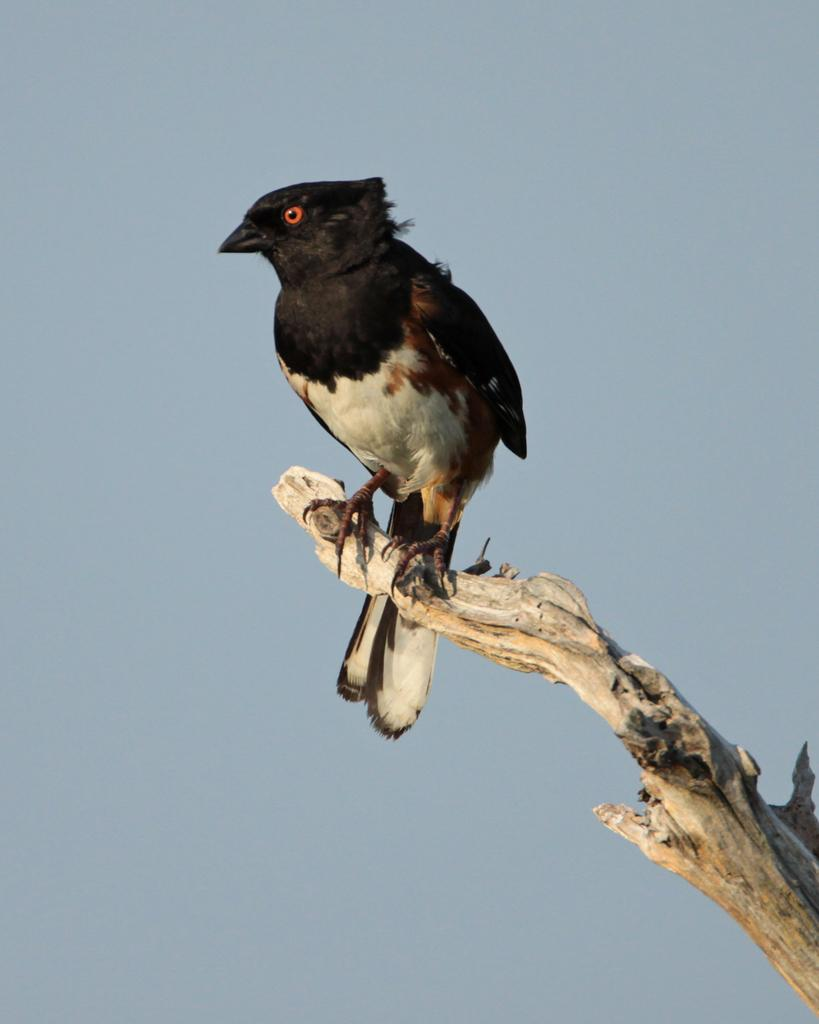What type of animal is in the image? There is a bird in the image. Where is the bird located? The bird is on a branch. What can be seen in the background of the image? The sky is visible in the background of the image. What type of juice is the bird drinking in the image? There is no juice present in the image; the bird is on a branch. 